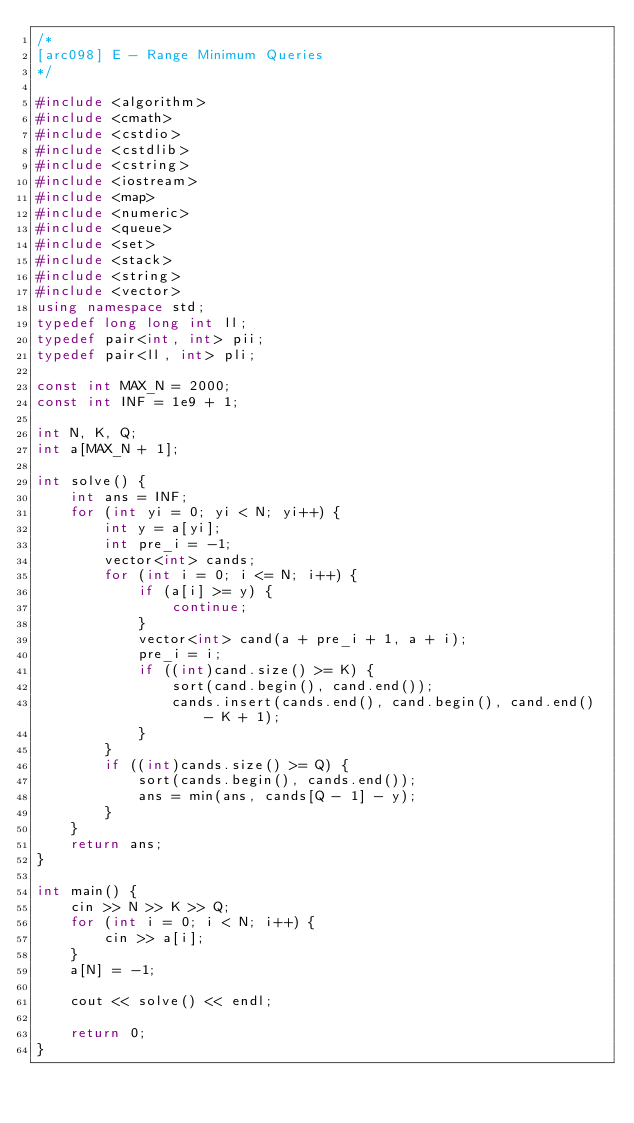<code> <loc_0><loc_0><loc_500><loc_500><_C++_>/*
[arc098] E - Range Minimum Queries
*/

#include <algorithm>
#include <cmath>
#include <cstdio>
#include <cstdlib>
#include <cstring>
#include <iostream>
#include <map>
#include <numeric>
#include <queue>
#include <set>
#include <stack>
#include <string>
#include <vector>
using namespace std;
typedef long long int ll;
typedef pair<int, int> pii;
typedef pair<ll, int> pli;

const int MAX_N = 2000;
const int INF = 1e9 + 1;

int N, K, Q;
int a[MAX_N + 1];

int solve() {
    int ans = INF;
    for (int yi = 0; yi < N; yi++) {
        int y = a[yi];
        int pre_i = -1;
        vector<int> cands;
        for (int i = 0; i <= N; i++) {
            if (a[i] >= y) {
                continue;
            }
            vector<int> cand(a + pre_i + 1, a + i);
            pre_i = i;
            if ((int)cand.size() >= K) {
                sort(cand.begin(), cand.end());
                cands.insert(cands.end(), cand.begin(), cand.end() - K + 1);
            }
        }
        if ((int)cands.size() >= Q) {
            sort(cands.begin(), cands.end());
            ans = min(ans, cands[Q - 1] - y);
        }
    }
    return ans;
}

int main() {
    cin >> N >> K >> Q;
    for (int i = 0; i < N; i++) {
        cin >> a[i];
    }
    a[N] = -1;

    cout << solve() << endl;

    return 0;
}
</code> 